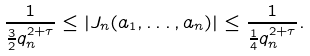Convert formula to latex. <formula><loc_0><loc_0><loc_500><loc_500>\frac { 1 } { { \frac { 3 } { 2 } } q _ { n } ^ { 2 + \tau } } \leq | J _ { n } ( a _ { 1 } , \dots , a _ { n } ) | \leq \frac { 1 } { { \frac { 1 } { 4 } } q _ { n } ^ { 2 + \tau } } .</formula> 